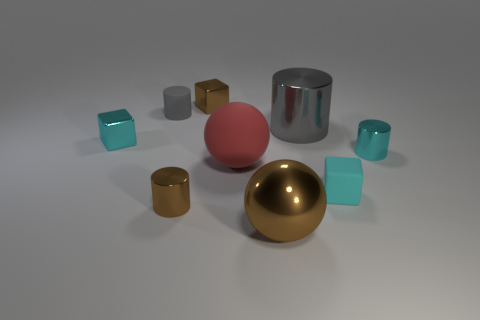Are there more cyan cubes than red matte cylinders?
Make the answer very short. Yes. How many things are tiny rubber objects left of the large gray cylinder or cyan metal cubes?
Make the answer very short. 2. Is the material of the red object the same as the small brown cylinder?
Give a very brief answer. No. What is the size of the other brown thing that is the same shape as the big matte thing?
Make the answer very short. Large. Does the big metal thing behind the brown cylinder have the same shape as the cyan shiny thing to the left of the cyan metallic cylinder?
Your answer should be compact. No. There is a metallic sphere; is its size the same as the cyan thing that is in front of the tiny cyan cylinder?
Give a very brief answer. No. How many other things are made of the same material as the large brown sphere?
Give a very brief answer. 5. There is a shiny cylinder left of the shiny cube that is right of the shiny object left of the brown cylinder; what color is it?
Keep it short and to the point. Brown. There is a metal thing that is both right of the large red ball and in front of the small cyan rubber object; what is its shape?
Ensure brevity in your answer.  Sphere. The large rubber sphere on the right side of the metallic thing that is on the left side of the tiny gray cylinder is what color?
Your answer should be compact. Red. 